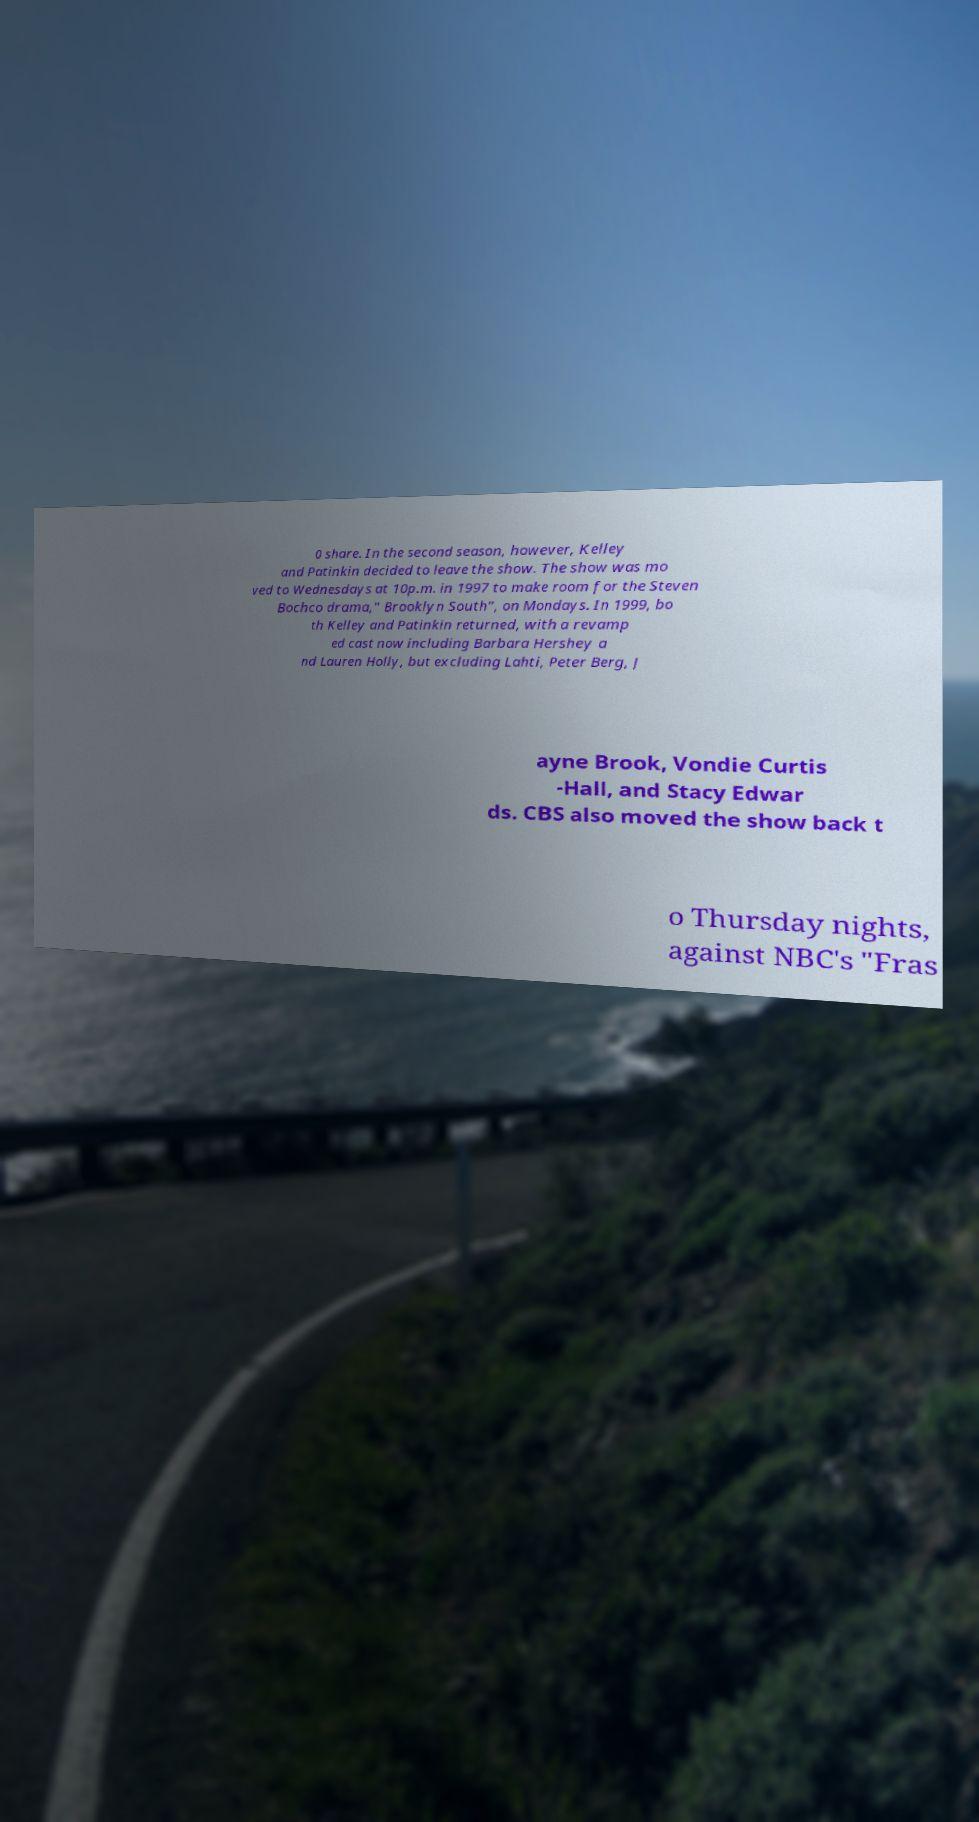What messages or text are displayed in this image? I need them in a readable, typed format. 0 share. In the second season, however, Kelley and Patinkin decided to leave the show. The show was mo ved to Wednesdays at 10p.m. in 1997 to make room for the Steven Bochco drama," Brooklyn South", on Mondays. In 1999, bo th Kelley and Patinkin returned, with a revamp ed cast now including Barbara Hershey a nd Lauren Holly, but excluding Lahti, Peter Berg, J ayne Brook, Vondie Curtis -Hall, and Stacy Edwar ds. CBS also moved the show back t o Thursday nights, against NBC's "Fras 